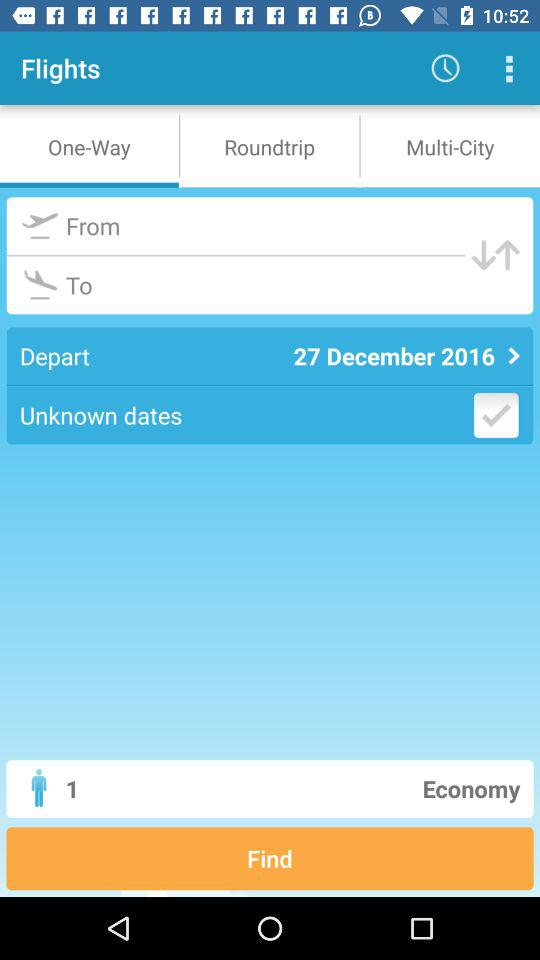How many people are in the party?
Answer the question using a single word or phrase. 1 